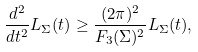Convert formula to latex. <formula><loc_0><loc_0><loc_500><loc_500>\frac { d ^ { 2 } } { d t ^ { 2 } } L _ { \Sigma } ( t ) \geq \frac { ( 2 \pi ) ^ { 2 } } { F _ { 3 } ( \Sigma ) ^ { 2 } } L _ { \Sigma } ( t ) ,</formula> 